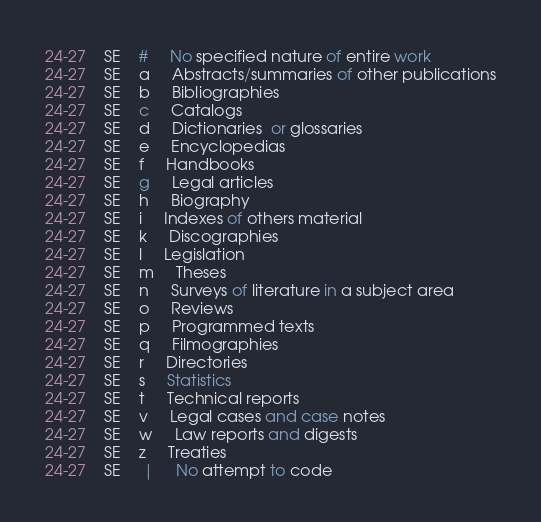<code> <loc_0><loc_0><loc_500><loc_500><_SQL_>24-27	SE	# 	 No specified nature of entire work 
24-27	SE	a 	 Abstracts/summaries of other publications
24-27	SE	b 	 Bibliographies 
24-27	SE	c 	 Catalogs 
24-27	SE	d 	 Dictionaries  or glossaries
24-27	SE	e 	 Encyclopedias 
24-27	SE	f 	 Handbooks 
24-27	SE	g 	 Legal articles 
24-27	SE	h 	 Biography 
24-27	SE	i 	 Indexes of others material
24-27	SE	k 	 Discographies 
24-27	SE	l 	 Legislation 
24-27	SE	m 	 Theses 
24-27	SE	n 	 Surveys of literature in a subject area 
24-27	SE	o 	 Reviews 
24-27	SE	p 	 Programmed texts 
24-27	SE	q 	 Filmographies 
24-27	SE	r 	 Directories 
24-27	SE	s 	 Statistics 
24-27	SE	t 	 Technical reports 
24-27	SE	v 	 Legal cases and case notes 
24-27	SE	w 	 Law reports and digests 
24-27	SE	z 	 Treaties 
24-27	SE	 | 	 No attempt to code
</code> 